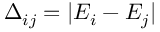Convert formula to latex. <formula><loc_0><loc_0><loc_500><loc_500>\Delta _ { i j } = | E _ { i } - E _ { j } |</formula> 